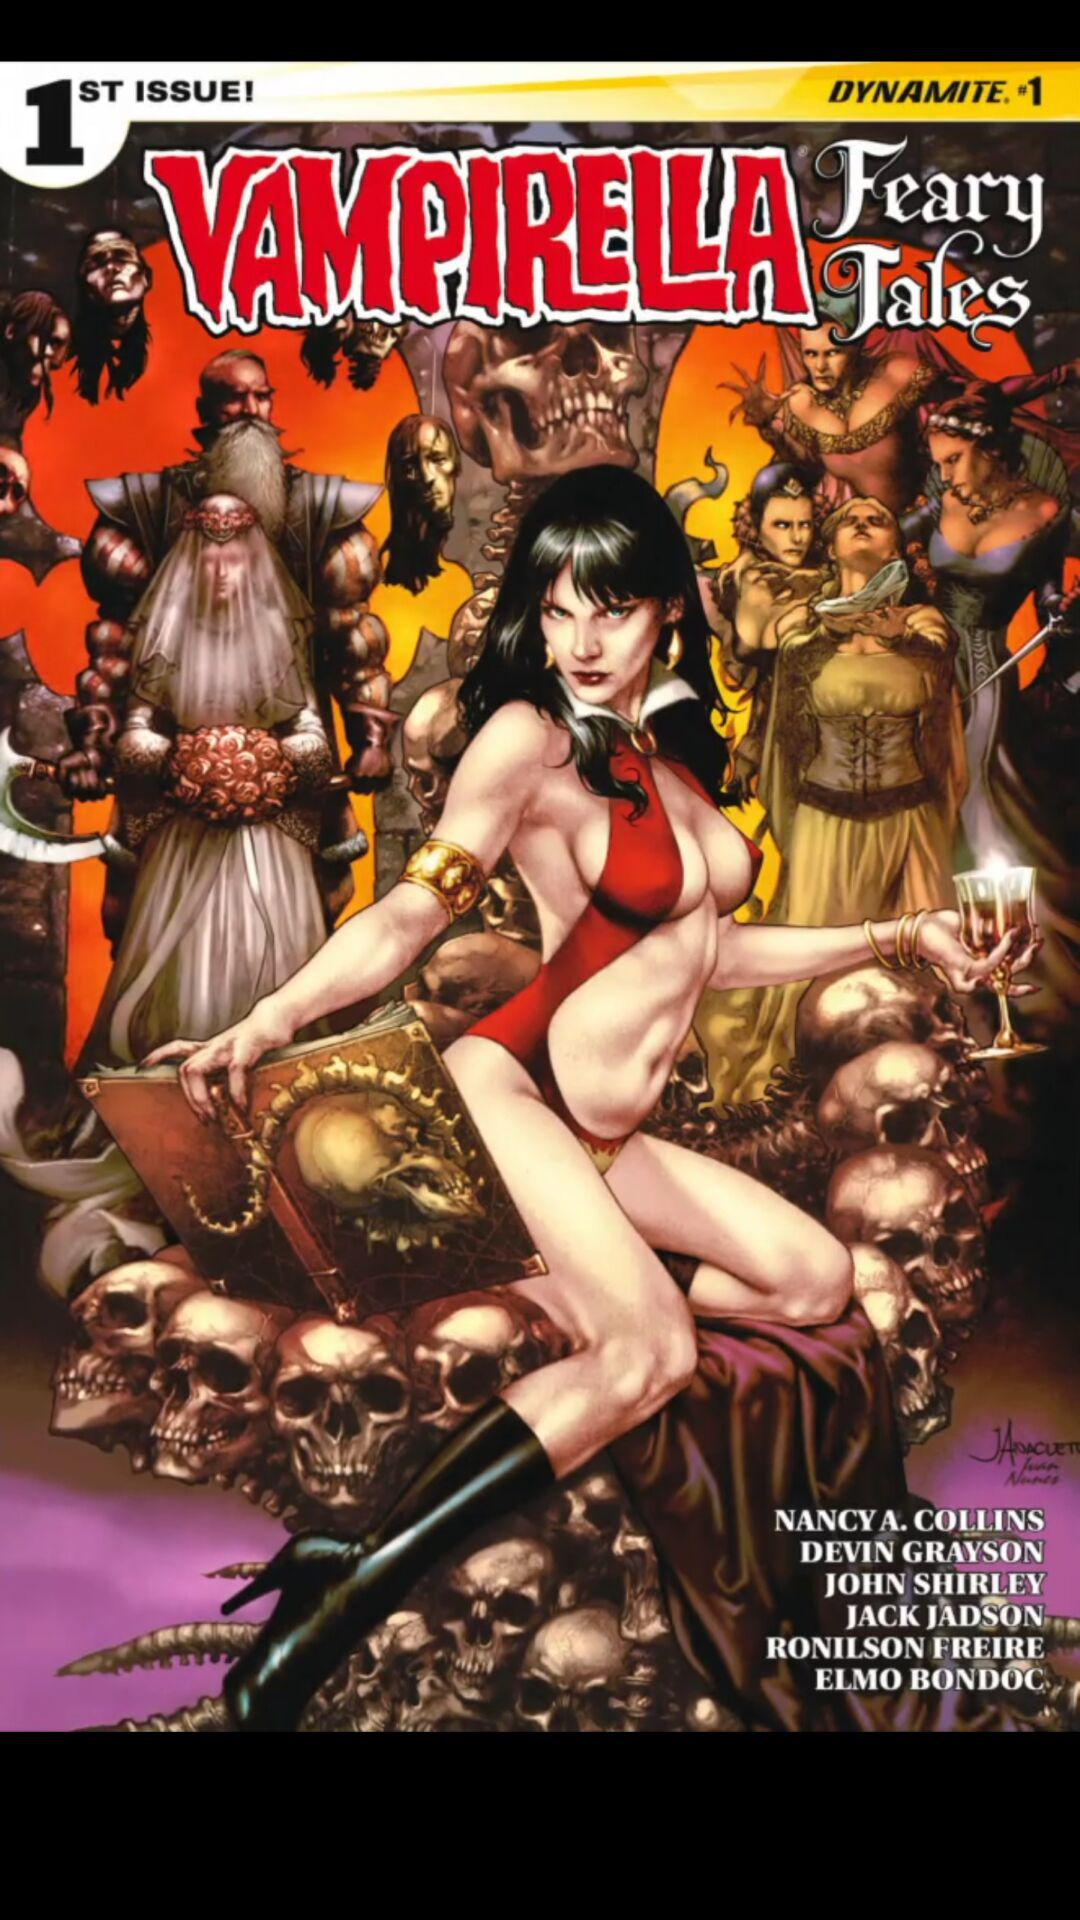Who are the illustrators of "VAMPIRELLA Feary Tales" book? The illustrators of "VAMPIRELLA Feary Tales" book are Jack Jadson, Ronilson Freire and Elmo Bondoc. 